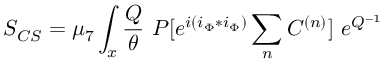<formula> <loc_0><loc_0><loc_500><loc_500>S _ { C S } = \mu _ { 7 } \int _ { x } { \frac { Q } { \theta } } P [ e ^ { i ( i _ { \Phi } * i _ { \Phi } ) } \sum _ { n } C ^ { ( n ) } ] e ^ { Q ^ { - 1 } }</formula> 